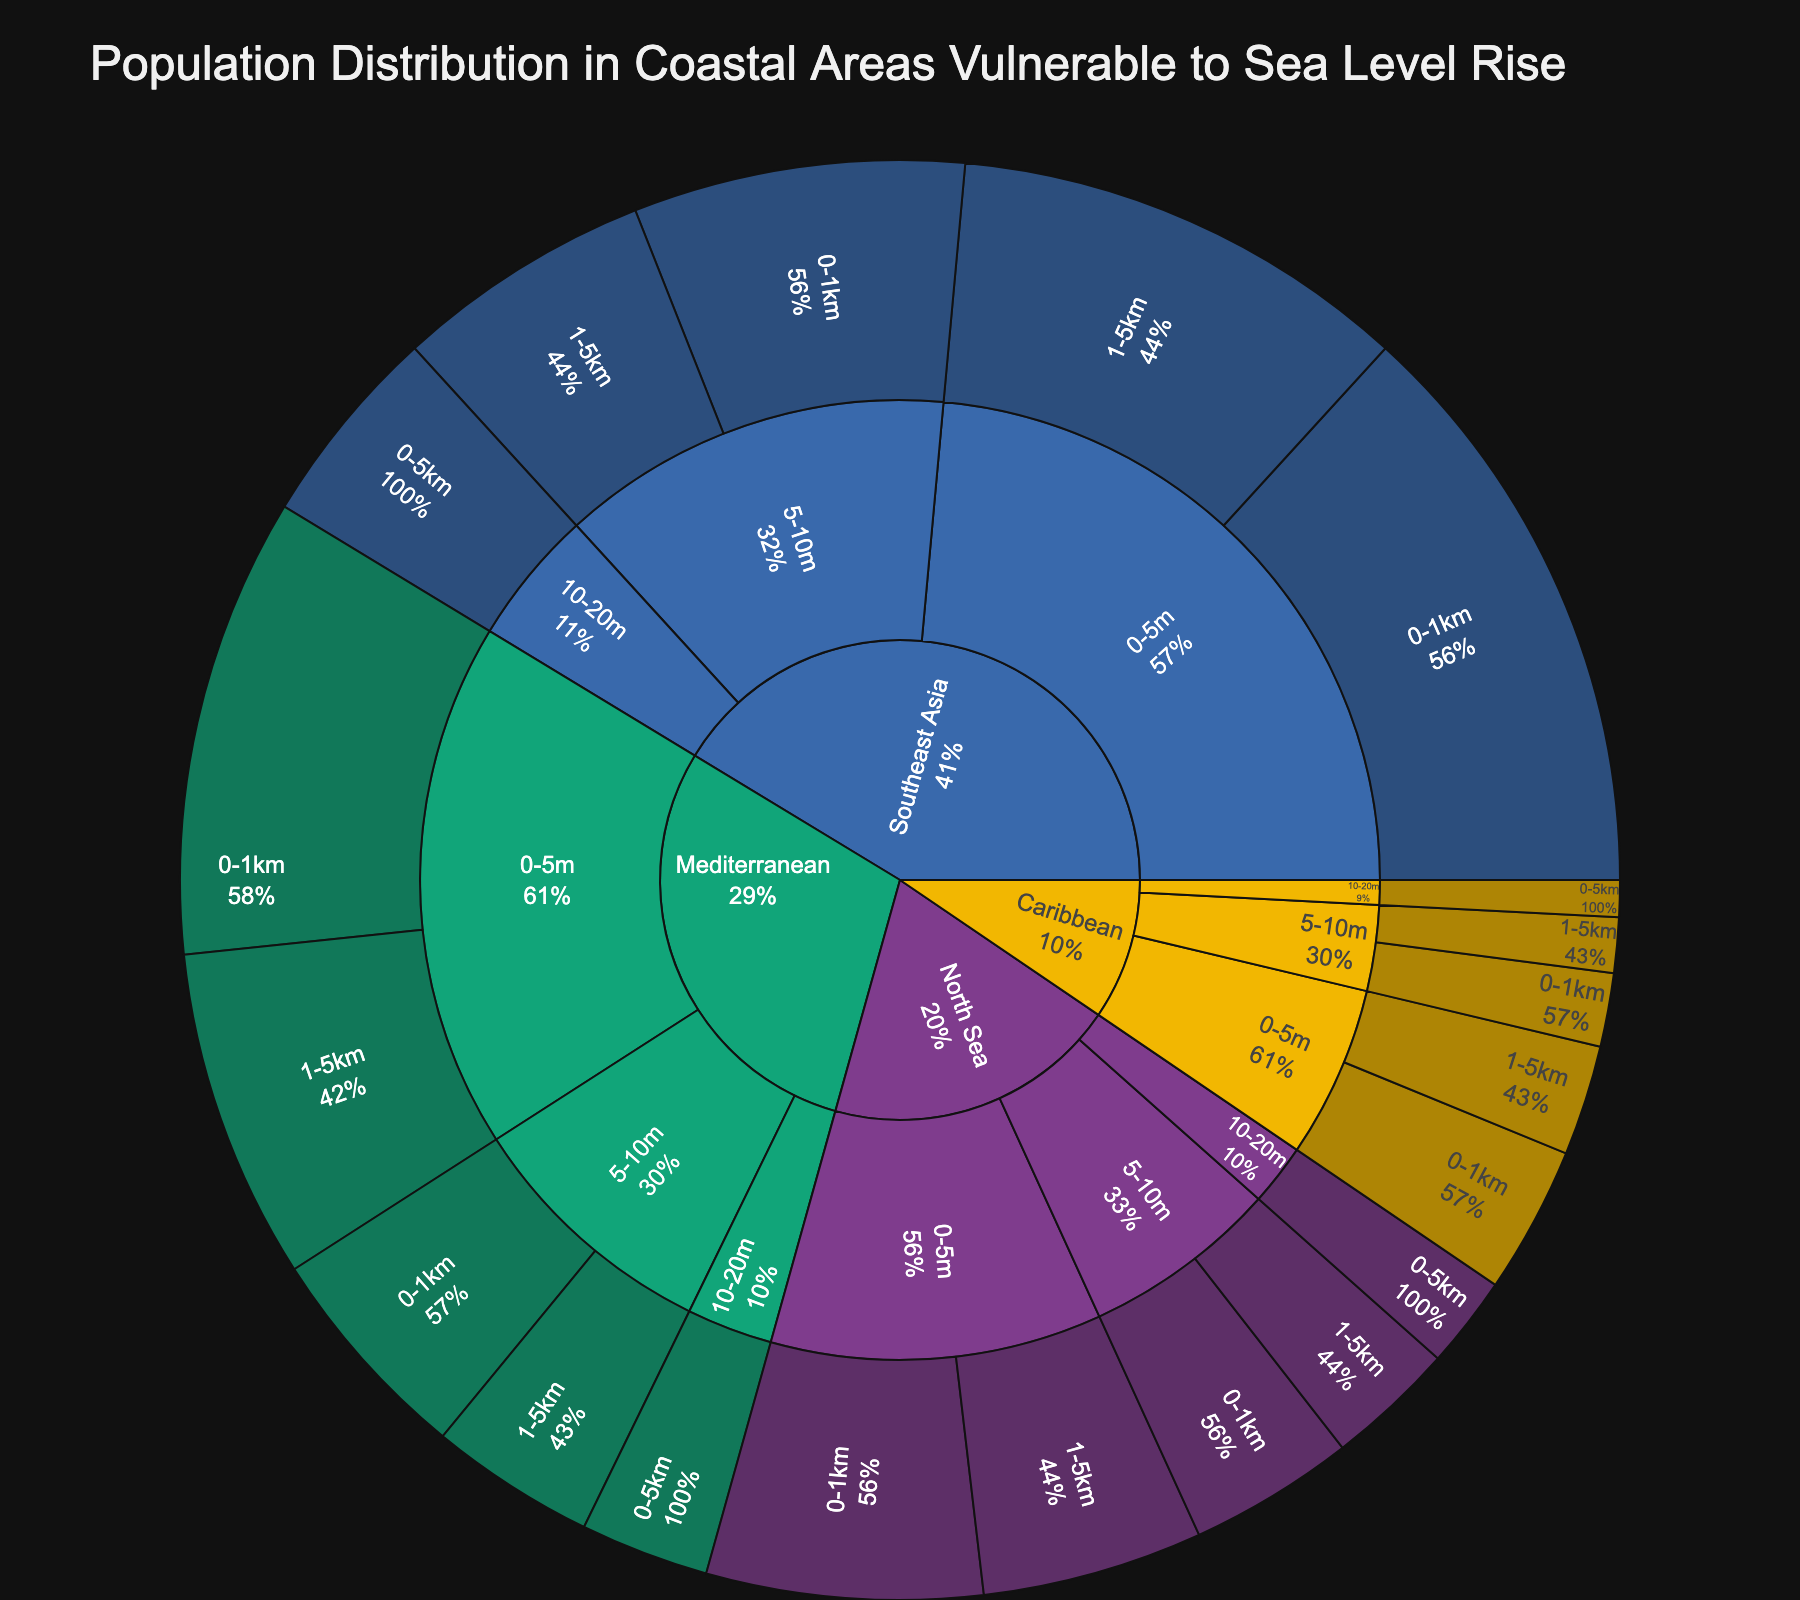What is the title of the Sunburst Plot? The title is displayed at the top of the plot and provides an overview of the data being visualized.
Answer: Population Distribution in Coastal Areas Vulnerable to Sea Level Rise Which region has the highest population in the 0-5m elevation and 0-1km distance category? Look under the '0-5m' elevation and '0-1km' distance for each region. Compare the population values.
Answer: Southeast Asia How many regions are displayed in the plot? Count the number of unique regions displayed at the first level of the sunburst plot.
Answer: 4 What is the combined population for the Mediterranean region across all elevation and distance categories? Sum the population values for all categories under the Mediterranean region.
Answer: 7,900,000 Which elevation category within the North Sea region has the smallest population? Look within the elevation categories under the North Sea region and find the one with the smallest value.
Answer: 10-20m Compare the total population of the Caribbean and North Sea regions. Which one is greater? Calculate the total population for both regions and compare. Caribbean: 2,300,000, North Sea: 4,550,000
Answer: North Sea What percentage of Southeast Asia's population resides in the 0-1km distance and 0-5m elevation category? Find the population for Southeast Asia in 0-1km and 0-5m and divide it by the total Southeast Asia population, then convert to percentage. (3,200,000 / 10,500,000) * 100
Answer: 30.48% What is the total population living in areas with elevations between 5-10m across all regions? Sum the population values for the 5-10m elevation category across all regions.
Answer: 6,500,000 How does the population in Southeast Asia's 5-10m elevation and 0-1km distance category compare to the Mediterranean in the same category? Look at the populations under the 5-10m elevation and 0-1km distance for both Southeast Asia and the Mediterranean. Southeast Asia: 1,800,000, Mediterranean: 1,200,000
Answer: Southeast Asia 